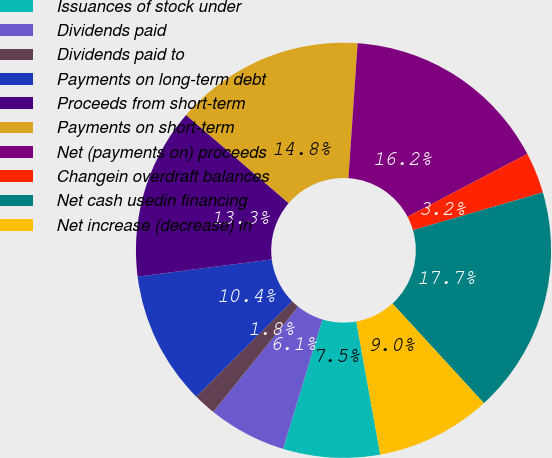Convert chart. <chart><loc_0><loc_0><loc_500><loc_500><pie_chart><fcel>Issuances of stock under<fcel>Dividends paid<fcel>Dividends paid to<fcel>Payments on long-term debt<fcel>Proceeds from short-term<fcel>Payments on short-term<fcel>Net (payments on) proceeds<fcel>Changein overdraft balances<fcel>Net cash usedin financing<fcel>Net increase (decrease) in<nl><fcel>7.54%<fcel>6.09%<fcel>1.75%<fcel>10.43%<fcel>13.33%<fcel>14.78%<fcel>16.23%<fcel>3.19%<fcel>17.67%<fcel>8.99%<nl></chart> 